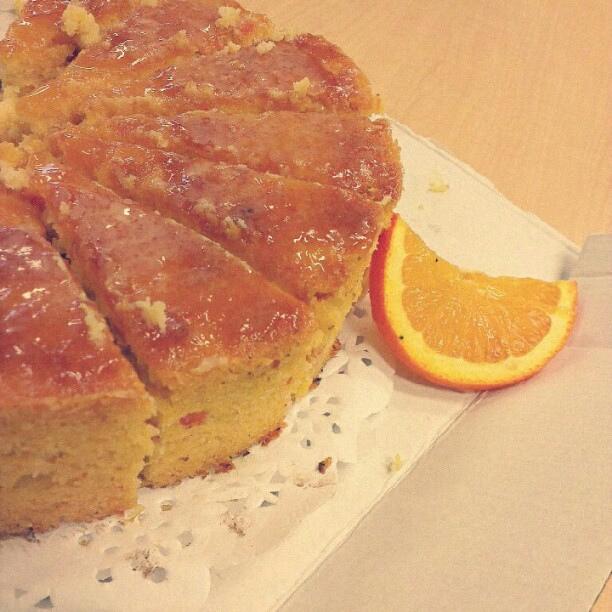Is that an orange or a lemon?
Quick response, please. Orange. What type of dish is this?
Keep it brief. Dessert. Would this be good for dessert?
Answer briefly. Yes. What fruit is shown?
Answer briefly. Orange. 